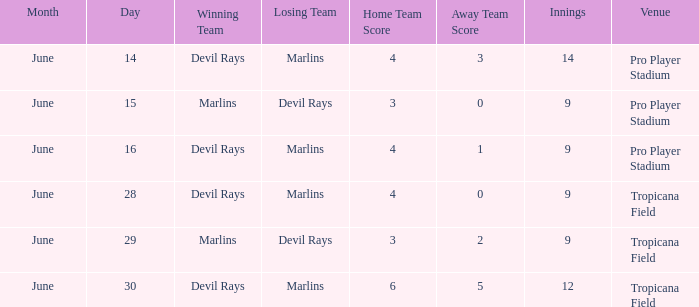What was the score of the game at pro player stadium on june 14? 4-3 (14 innings). 